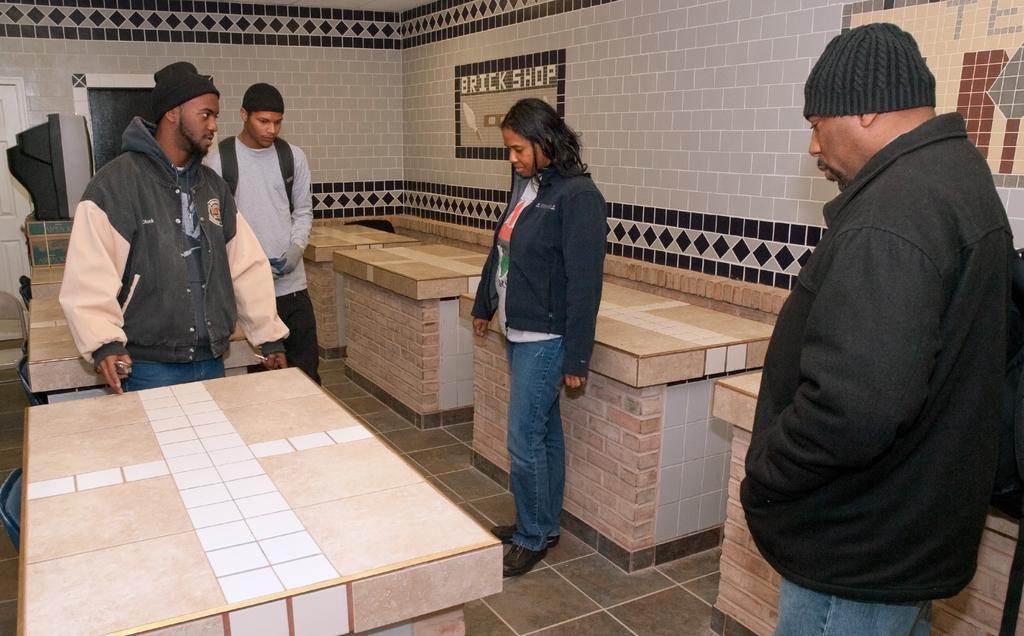Describe this image in one or two sentences. In the image we can see there are people standing on the ground and there are tables which are made up of stone bricks. Behind there are tiles on the wall. 